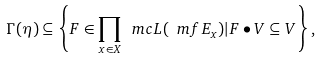Convert formula to latex. <formula><loc_0><loc_0><loc_500><loc_500>\Gamma ( \eta ) \subseteq \left \{ F \in \prod _ { x \in X } \ m c { L } ( \ m f { E } _ { x } ) | F \bullet V \subseteq V \right \} ,</formula> 